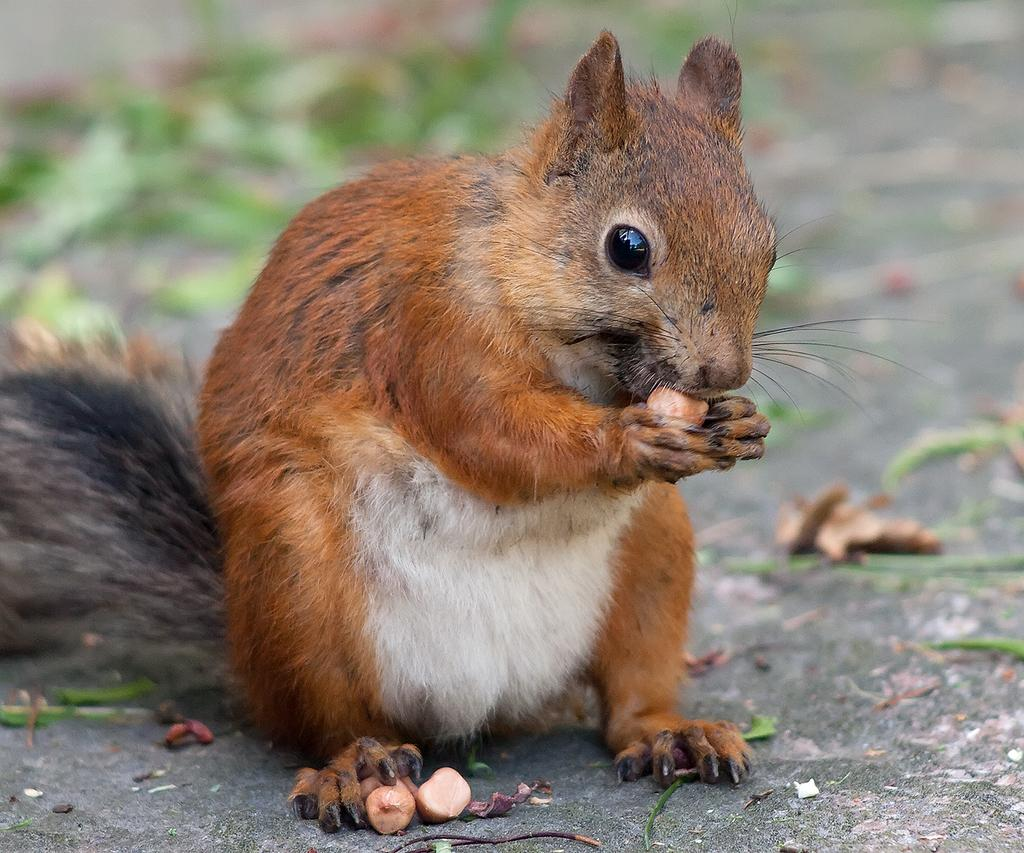Where was the image taken? The image was taken outdoors. What can be seen at the bottom of the image? There is a road at the bottom of the image. What is the main subject in the middle of the image? There is a squirrel in the middle of the image. What is the squirrel doing in the image? The squirrel is eating nuts. How many cats are visible in the image? There are no cats present in the image. What scent can be detected from the zebra in the image? There is no zebra present in the image, so it is not possible to detect any scent. 